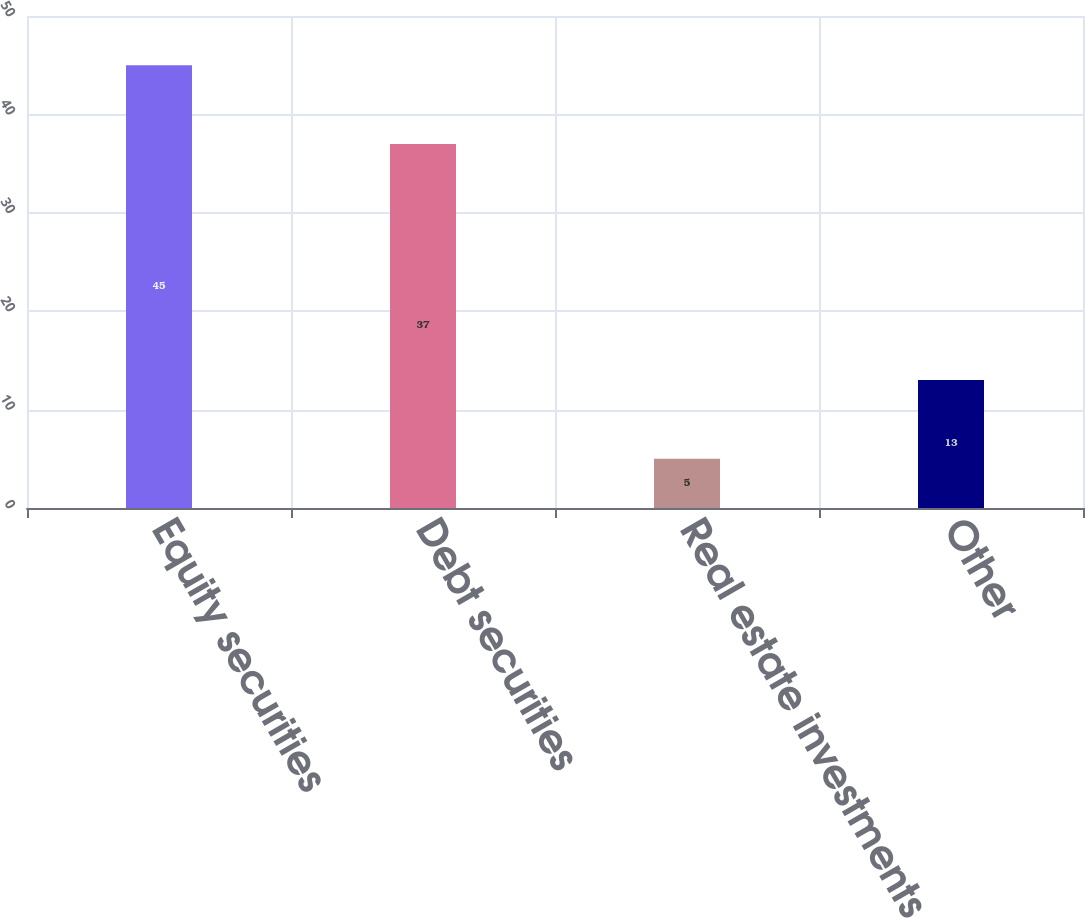<chart> <loc_0><loc_0><loc_500><loc_500><bar_chart><fcel>Equity securities<fcel>Debt securities<fcel>Real estate investments<fcel>Other<nl><fcel>45<fcel>37<fcel>5<fcel>13<nl></chart> 